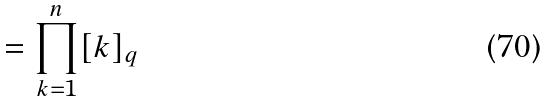Convert formula to latex. <formula><loc_0><loc_0><loc_500><loc_500>= \prod _ { k = 1 } ^ { n } [ k ] _ { q }</formula> 